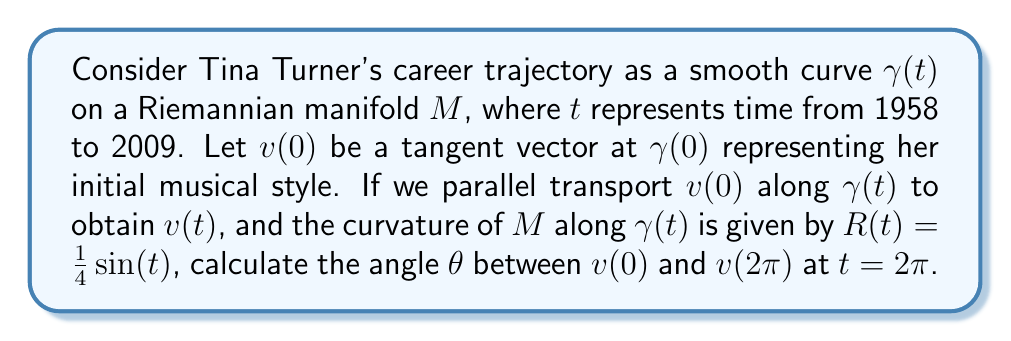What is the answer to this math problem? To solve this problem, we'll use the concept of holonomy in differential geometry. The angle between the initial vector $v(0)$ and the parallel transported vector $v(2\pi)$ is related to the integral of the curvature along the path.

Step 1: The holonomy angle $\theta$ is given by the integral of the curvature over the area enclosed by the path:

$$\theta = \int_0^{2\pi} R(t) dt$$

Step 2: Substitute the given curvature function:

$$\theta = \int_0^{2\pi} \frac{1}{4}\sin(t) dt$$

Step 3: Integrate using the substitution $u = -\cos(t)$, $du = \sin(t)dt$:

$$\theta = \frac{1}{4}[-\cos(t)]_0^{2\pi}$$

Step 4: Evaluate the integral:

$$\theta = \frac{1}{4}[-\cos(2\pi) + \cos(0)]$$

Step 5: Simplify:

$$\theta = \frac{1}{4}[-1 + 1] = 0$$

Therefore, the angle between $v(0)$ and $v(2\pi)$ is 0 radians, meaning the vector returns to its original orientation after one full cycle of Tina Turner's career.
Answer: $0$ radians 